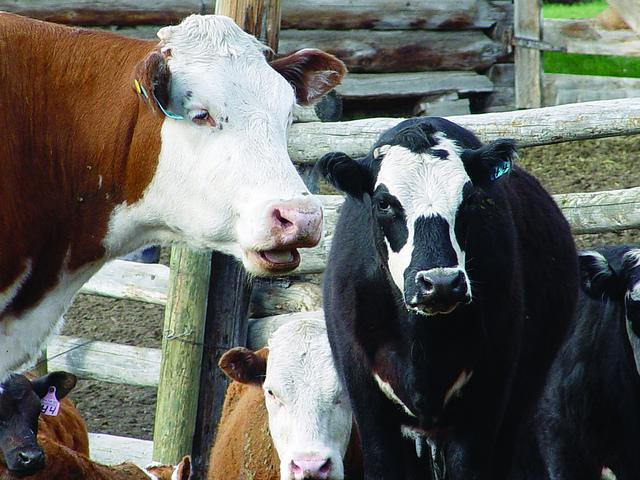Who put the tag on the cows ear? farmer 